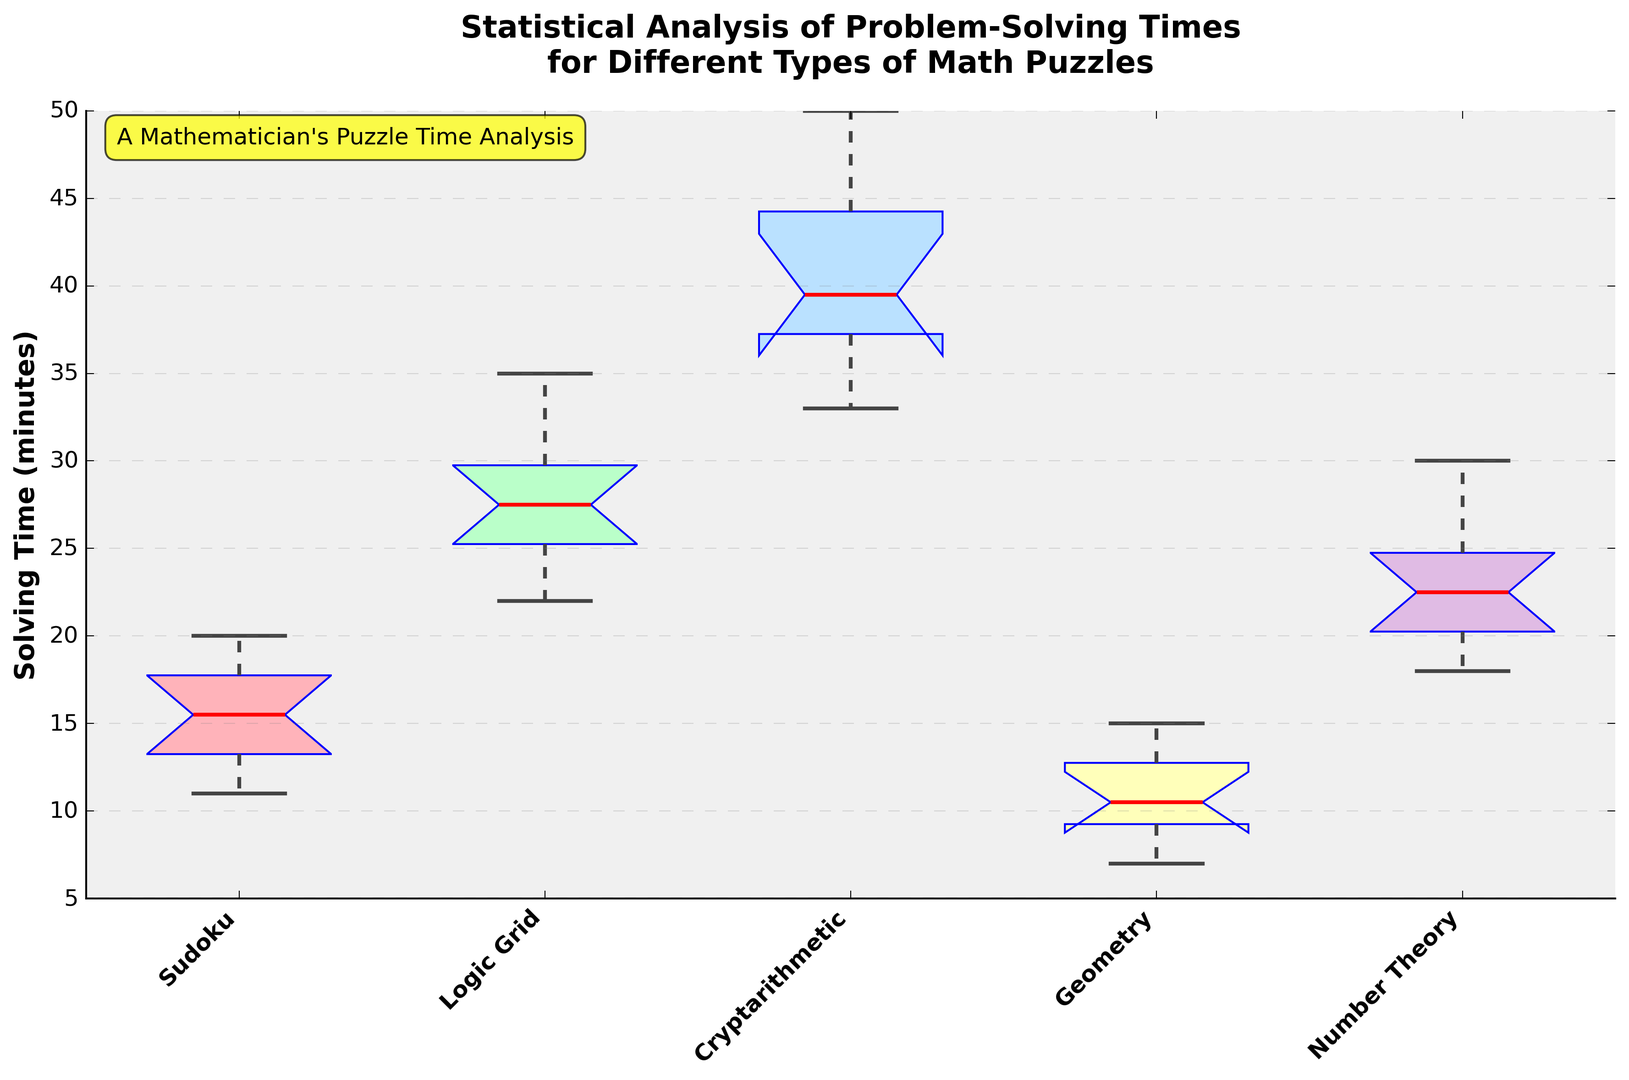What is the median solving time for Sudoku puzzles? The median solving time is shown by the red line inside the box corresponding to Sudoku in the box plot.
Answer: 15 Which puzzle type has the longest median solving time? We look for the red line inside the box that is the highest on the y-axis. This is for Cryptarithmetic puzzles.
Answer: Cryptarithmetic Which puzzle type has the shortest range of solving times? The range is the distance between the top and bottom whiskers for each box. The shortest whisker range is that of Geometry puzzles.
Answer: Geometry What is the interquartile range (IQR) for Logic Grid puzzles? The IQR is the range between the first (Q1) and third quartiles (Q3) of the box plot. For Logic Grid puzzles, it is the height of the box between the lower quartile (approx. 25) and upper quartile (approx. 30). \(30 - 25 = 5\).
Answer: 5 Are there any outliers for Number Theory puzzles? Outliers are shown as individual points outside the whiskers. Based on the figure, Number Theory puzzles do not have outliers.
Answer: No Between Sudoku and Geometry puzzles, which has a higher maximum solving time? The maximum solving time is shown by the top whisker or any outliers for each puzzle type. Sudoku's highest whisker is at about 20, and Geometry's highest whisker is at 15.
Answer: Sudoku Which puzzle type has the smallest median solving time? The median is indicated by the red line inside each box. The smallest red line (lowest on the y-axis) is for Geometry puzzles.
Answer: Geometry How does the interquartile range (IQR) of Sudoku puzzles compare to the interquartile range of Cryptarithmetic puzzles? The IQR for Sudoku is the height of the box between the first and third quartiles (approximately 12 to 18), so \(18 - 12 = 6\). For Cryptarithmetic, the IQR is approximately from 37 to 45, so \(45 - 37 = 8\). The IQR for Cryptarithmetic puzzles is greater than for Sudoku puzzles.
Answer: Cryptarithmetic > Sudoku 